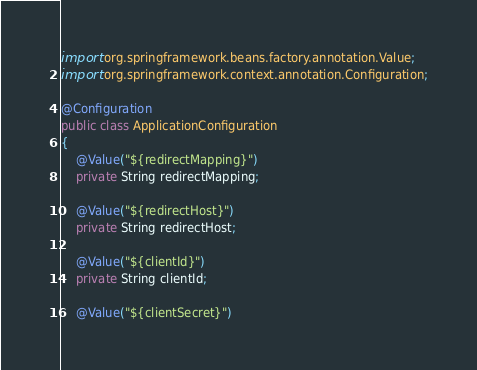<code> <loc_0><loc_0><loc_500><loc_500><_Java_>import org.springframework.beans.factory.annotation.Value;
import org.springframework.context.annotation.Configuration;

@Configuration
public class ApplicationConfiguration
{
	@Value("${redirectMapping}")
	private String redirectMapping;

    @Value("${redirectHost}")
    private String redirectHost;

    @Value("${clientId}")
	private String clientId;

    @Value("${clientSecret}")</code> 